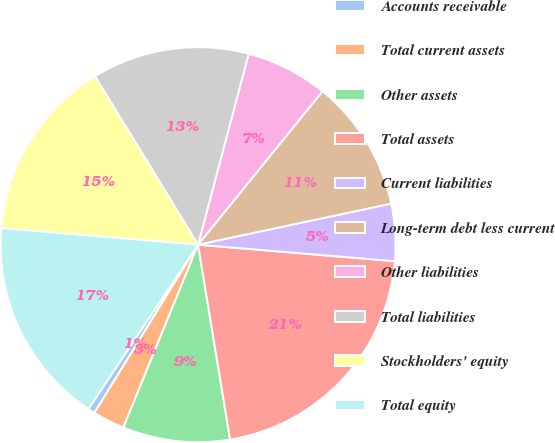Convert chart to OTSL. <chart><loc_0><loc_0><loc_500><loc_500><pie_chart><fcel>Accounts receivable<fcel>Total current assets<fcel>Other assets<fcel>Total assets<fcel>Current liabilities<fcel>Long-term debt less current<fcel>Other liabilities<fcel>Total liabilities<fcel>Stockholders' equity<fcel>Total equity<nl><fcel>0.57%<fcel>2.62%<fcel>8.77%<fcel>21.07%<fcel>4.67%<fcel>10.82%<fcel>6.72%<fcel>12.87%<fcel>14.92%<fcel>16.97%<nl></chart> 